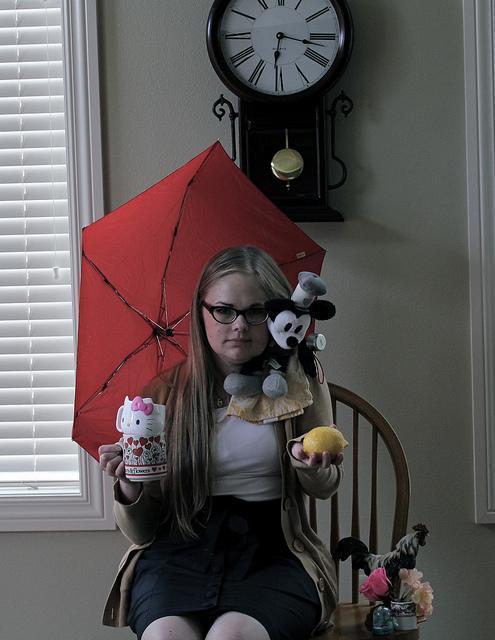How many other animals besides the giraffe are in the picture?
Give a very brief answer. 0. 